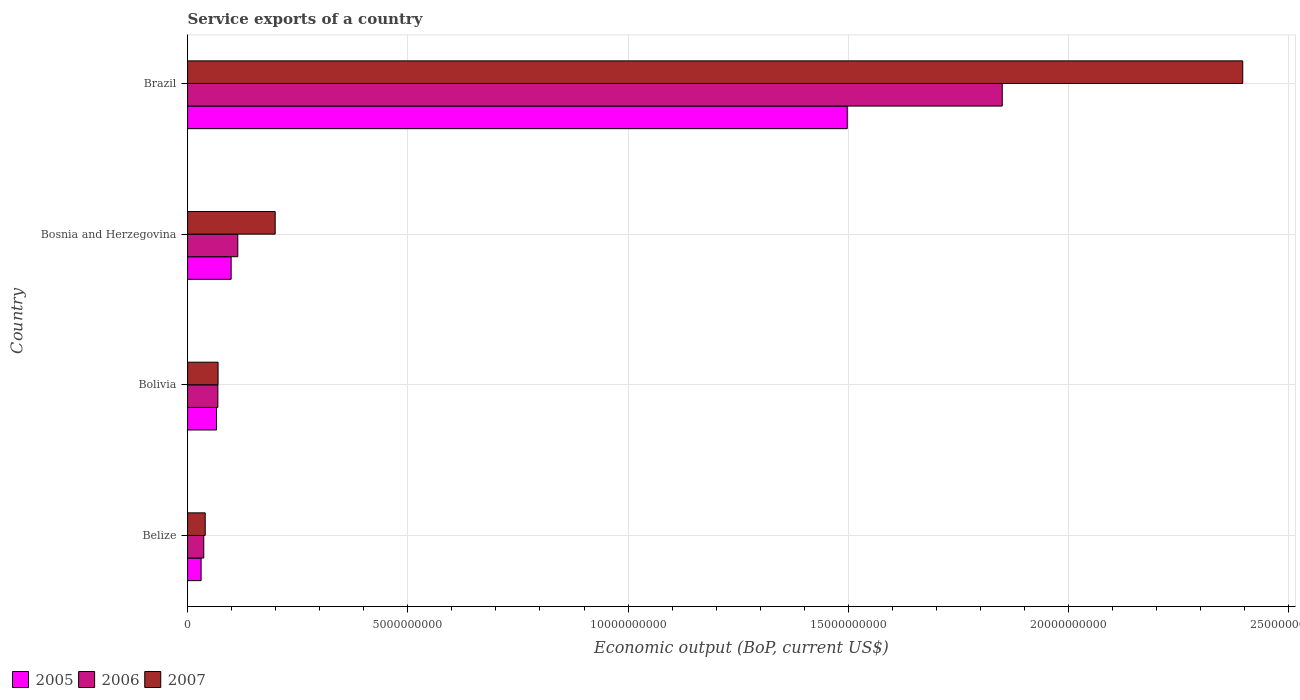How many groups of bars are there?
Make the answer very short. 4. Are the number of bars per tick equal to the number of legend labels?
Your response must be concise. Yes. Are the number of bars on each tick of the Y-axis equal?
Offer a terse response. Yes. How many bars are there on the 4th tick from the top?
Make the answer very short. 3. What is the label of the 2nd group of bars from the top?
Your response must be concise. Bosnia and Herzegovina. In how many cases, is the number of bars for a given country not equal to the number of legend labels?
Offer a very short reply. 0. What is the service exports in 2005 in Bolivia?
Your answer should be very brief. 6.57e+08. Across all countries, what is the maximum service exports in 2005?
Give a very brief answer. 1.50e+1. Across all countries, what is the minimum service exports in 2007?
Provide a succinct answer. 4.00e+08. In which country was the service exports in 2006 minimum?
Your response must be concise. Belize. What is the total service exports in 2007 in the graph?
Your response must be concise. 2.70e+1. What is the difference between the service exports in 2005 in Bolivia and that in Brazil?
Keep it short and to the point. -1.43e+1. What is the difference between the service exports in 2006 in Bolivia and the service exports in 2005 in Belize?
Provide a short and direct response. 3.80e+08. What is the average service exports in 2007 per country?
Keep it short and to the point. 6.76e+09. What is the difference between the service exports in 2007 and service exports in 2005 in Bolivia?
Give a very brief answer. 3.47e+07. What is the ratio of the service exports in 2006 in Belize to that in Brazil?
Provide a succinct answer. 0.02. What is the difference between the highest and the second highest service exports in 2005?
Your answer should be compact. 1.40e+1. What is the difference between the highest and the lowest service exports in 2007?
Make the answer very short. 2.36e+1. In how many countries, is the service exports in 2006 greater than the average service exports in 2006 taken over all countries?
Provide a short and direct response. 1. What does the 2nd bar from the top in Belize represents?
Provide a succinct answer. 2006. How many bars are there?
Provide a short and direct response. 12. Are all the bars in the graph horizontal?
Provide a short and direct response. Yes. How many countries are there in the graph?
Offer a terse response. 4. What is the difference between two consecutive major ticks on the X-axis?
Give a very brief answer. 5.00e+09. Are the values on the major ticks of X-axis written in scientific E-notation?
Your response must be concise. No. Does the graph contain any zero values?
Provide a succinct answer. No. What is the title of the graph?
Provide a short and direct response. Service exports of a country. Does "1961" appear as one of the legend labels in the graph?
Make the answer very short. No. What is the label or title of the X-axis?
Offer a very short reply. Economic output (BoP, current US$). What is the label or title of the Y-axis?
Give a very brief answer. Country. What is the Economic output (BoP, current US$) in 2005 in Belize?
Your answer should be compact. 3.07e+08. What is the Economic output (BoP, current US$) in 2006 in Belize?
Provide a short and direct response. 3.67e+08. What is the Economic output (BoP, current US$) in 2007 in Belize?
Your answer should be very brief. 4.00e+08. What is the Economic output (BoP, current US$) of 2005 in Bolivia?
Provide a short and direct response. 6.57e+08. What is the Economic output (BoP, current US$) of 2006 in Bolivia?
Provide a succinct answer. 6.87e+08. What is the Economic output (BoP, current US$) in 2007 in Bolivia?
Provide a short and direct response. 6.92e+08. What is the Economic output (BoP, current US$) in 2005 in Bosnia and Herzegovina?
Provide a short and direct response. 9.89e+08. What is the Economic output (BoP, current US$) in 2006 in Bosnia and Herzegovina?
Provide a succinct answer. 1.14e+09. What is the Economic output (BoP, current US$) in 2007 in Bosnia and Herzegovina?
Ensure brevity in your answer.  1.99e+09. What is the Economic output (BoP, current US$) in 2005 in Brazil?
Make the answer very short. 1.50e+1. What is the Economic output (BoP, current US$) of 2006 in Brazil?
Offer a very short reply. 1.85e+1. What is the Economic output (BoP, current US$) in 2007 in Brazil?
Give a very brief answer. 2.40e+1. Across all countries, what is the maximum Economic output (BoP, current US$) in 2005?
Provide a succinct answer. 1.50e+1. Across all countries, what is the maximum Economic output (BoP, current US$) in 2006?
Provide a short and direct response. 1.85e+1. Across all countries, what is the maximum Economic output (BoP, current US$) in 2007?
Offer a terse response. 2.40e+1. Across all countries, what is the minimum Economic output (BoP, current US$) of 2005?
Ensure brevity in your answer.  3.07e+08. Across all countries, what is the minimum Economic output (BoP, current US$) of 2006?
Make the answer very short. 3.67e+08. Across all countries, what is the minimum Economic output (BoP, current US$) of 2007?
Your answer should be very brief. 4.00e+08. What is the total Economic output (BoP, current US$) of 2005 in the graph?
Your response must be concise. 1.69e+1. What is the total Economic output (BoP, current US$) in 2006 in the graph?
Your answer should be compact. 2.07e+1. What is the total Economic output (BoP, current US$) of 2007 in the graph?
Keep it short and to the point. 2.70e+1. What is the difference between the Economic output (BoP, current US$) in 2005 in Belize and that in Bolivia?
Keep it short and to the point. -3.50e+08. What is the difference between the Economic output (BoP, current US$) in 2006 in Belize and that in Bolivia?
Give a very brief answer. -3.20e+08. What is the difference between the Economic output (BoP, current US$) in 2007 in Belize and that in Bolivia?
Ensure brevity in your answer.  -2.92e+08. What is the difference between the Economic output (BoP, current US$) of 2005 in Belize and that in Bosnia and Herzegovina?
Your response must be concise. -6.82e+08. What is the difference between the Economic output (BoP, current US$) in 2006 in Belize and that in Bosnia and Herzegovina?
Your response must be concise. -7.73e+08. What is the difference between the Economic output (BoP, current US$) of 2007 in Belize and that in Bosnia and Herzegovina?
Your response must be concise. -1.59e+09. What is the difference between the Economic output (BoP, current US$) in 2005 in Belize and that in Brazil?
Give a very brief answer. -1.47e+1. What is the difference between the Economic output (BoP, current US$) in 2006 in Belize and that in Brazil?
Your answer should be compact. -1.81e+1. What is the difference between the Economic output (BoP, current US$) in 2007 in Belize and that in Brazil?
Give a very brief answer. -2.36e+1. What is the difference between the Economic output (BoP, current US$) of 2005 in Bolivia and that in Bosnia and Herzegovina?
Provide a short and direct response. -3.32e+08. What is the difference between the Economic output (BoP, current US$) in 2006 in Bolivia and that in Bosnia and Herzegovina?
Offer a very short reply. -4.52e+08. What is the difference between the Economic output (BoP, current US$) in 2007 in Bolivia and that in Bosnia and Herzegovina?
Offer a terse response. -1.30e+09. What is the difference between the Economic output (BoP, current US$) of 2005 in Bolivia and that in Brazil?
Keep it short and to the point. -1.43e+1. What is the difference between the Economic output (BoP, current US$) in 2006 in Bolivia and that in Brazil?
Give a very brief answer. -1.78e+1. What is the difference between the Economic output (BoP, current US$) in 2007 in Bolivia and that in Brazil?
Your answer should be compact. -2.33e+1. What is the difference between the Economic output (BoP, current US$) of 2005 in Bosnia and Herzegovina and that in Brazil?
Your answer should be compact. -1.40e+1. What is the difference between the Economic output (BoP, current US$) of 2006 in Bosnia and Herzegovina and that in Brazil?
Make the answer very short. -1.74e+1. What is the difference between the Economic output (BoP, current US$) in 2007 in Bosnia and Herzegovina and that in Brazil?
Offer a terse response. -2.20e+1. What is the difference between the Economic output (BoP, current US$) in 2005 in Belize and the Economic output (BoP, current US$) in 2006 in Bolivia?
Give a very brief answer. -3.80e+08. What is the difference between the Economic output (BoP, current US$) in 2005 in Belize and the Economic output (BoP, current US$) in 2007 in Bolivia?
Offer a very short reply. -3.85e+08. What is the difference between the Economic output (BoP, current US$) in 2006 in Belize and the Economic output (BoP, current US$) in 2007 in Bolivia?
Your answer should be very brief. -3.25e+08. What is the difference between the Economic output (BoP, current US$) in 2005 in Belize and the Economic output (BoP, current US$) in 2006 in Bosnia and Herzegovina?
Provide a short and direct response. -8.33e+08. What is the difference between the Economic output (BoP, current US$) of 2005 in Belize and the Economic output (BoP, current US$) of 2007 in Bosnia and Herzegovina?
Provide a succinct answer. -1.68e+09. What is the difference between the Economic output (BoP, current US$) of 2006 in Belize and the Economic output (BoP, current US$) of 2007 in Bosnia and Herzegovina?
Provide a succinct answer. -1.62e+09. What is the difference between the Economic output (BoP, current US$) in 2005 in Belize and the Economic output (BoP, current US$) in 2006 in Brazil?
Keep it short and to the point. -1.82e+1. What is the difference between the Economic output (BoP, current US$) in 2005 in Belize and the Economic output (BoP, current US$) in 2007 in Brazil?
Ensure brevity in your answer.  -2.36e+1. What is the difference between the Economic output (BoP, current US$) of 2006 in Belize and the Economic output (BoP, current US$) of 2007 in Brazil?
Ensure brevity in your answer.  -2.36e+1. What is the difference between the Economic output (BoP, current US$) in 2005 in Bolivia and the Economic output (BoP, current US$) in 2006 in Bosnia and Herzegovina?
Keep it short and to the point. -4.83e+08. What is the difference between the Economic output (BoP, current US$) in 2005 in Bolivia and the Economic output (BoP, current US$) in 2007 in Bosnia and Herzegovina?
Keep it short and to the point. -1.33e+09. What is the difference between the Economic output (BoP, current US$) in 2006 in Bolivia and the Economic output (BoP, current US$) in 2007 in Bosnia and Herzegovina?
Make the answer very short. -1.30e+09. What is the difference between the Economic output (BoP, current US$) of 2005 in Bolivia and the Economic output (BoP, current US$) of 2006 in Brazil?
Your answer should be very brief. -1.78e+1. What is the difference between the Economic output (BoP, current US$) in 2005 in Bolivia and the Economic output (BoP, current US$) in 2007 in Brazil?
Offer a very short reply. -2.33e+1. What is the difference between the Economic output (BoP, current US$) in 2006 in Bolivia and the Economic output (BoP, current US$) in 2007 in Brazil?
Make the answer very short. -2.33e+1. What is the difference between the Economic output (BoP, current US$) of 2005 in Bosnia and Herzegovina and the Economic output (BoP, current US$) of 2006 in Brazil?
Your response must be concise. -1.75e+1. What is the difference between the Economic output (BoP, current US$) in 2005 in Bosnia and Herzegovina and the Economic output (BoP, current US$) in 2007 in Brazil?
Your answer should be very brief. -2.30e+1. What is the difference between the Economic output (BoP, current US$) in 2006 in Bosnia and Herzegovina and the Economic output (BoP, current US$) in 2007 in Brazil?
Offer a terse response. -2.28e+1. What is the average Economic output (BoP, current US$) of 2005 per country?
Offer a terse response. 4.23e+09. What is the average Economic output (BoP, current US$) in 2006 per country?
Offer a terse response. 5.17e+09. What is the average Economic output (BoP, current US$) in 2007 per country?
Your response must be concise. 6.76e+09. What is the difference between the Economic output (BoP, current US$) of 2005 and Economic output (BoP, current US$) of 2006 in Belize?
Make the answer very short. -6.01e+07. What is the difference between the Economic output (BoP, current US$) in 2005 and Economic output (BoP, current US$) in 2007 in Belize?
Your answer should be very brief. -9.31e+07. What is the difference between the Economic output (BoP, current US$) in 2006 and Economic output (BoP, current US$) in 2007 in Belize?
Give a very brief answer. -3.31e+07. What is the difference between the Economic output (BoP, current US$) of 2005 and Economic output (BoP, current US$) of 2006 in Bolivia?
Keep it short and to the point. -3.02e+07. What is the difference between the Economic output (BoP, current US$) of 2005 and Economic output (BoP, current US$) of 2007 in Bolivia?
Provide a succinct answer. -3.47e+07. What is the difference between the Economic output (BoP, current US$) of 2006 and Economic output (BoP, current US$) of 2007 in Bolivia?
Ensure brevity in your answer.  -4.51e+06. What is the difference between the Economic output (BoP, current US$) of 2005 and Economic output (BoP, current US$) of 2006 in Bosnia and Herzegovina?
Ensure brevity in your answer.  -1.51e+08. What is the difference between the Economic output (BoP, current US$) in 2005 and Economic output (BoP, current US$) in 2007 in Bosnia and Herzegovina?
Provide a short and direct response. -1.00e+09. What is the difference between the Economic output (BoP, current US$) of 2006 and Economic output (BoP, current US$) of 2007 in Bosnia and Herzegovina?
Your response must be concise. -8.49e+08. What is the difference between the Economic output (BoP, current US$) in 2005 and Economic output (BoP, current US$) in 2006 in Brazil?
Make the answer very short. -3.52e+09. What is the difference between the Economic output (BoP, current US$) of 2005 and Economic output (BoP, current US$) of 2007 in Brazil?
Keep it short and to the point. -8.98e+09. What is the difference between the Economic output (BoP, current US$) of 2006 and Economic output (BoP, current US$) of 2007 in Brazil?
Keep it short and to the point. -5.46e+09. What is the ratio of the Economic output (BoP, current US$) in 2005 in Belize to that in Bolivia?
Offer a terse response. 0.47. What is the ratio of the Economic output (BoP, current US$) of 2006 in Belize to that in Bolivia?
Your answer should be compact. 0.53. What is the ratio of the Economic output (BoP, current US$) in 2007 in Belize to that in Bolivia?
Make the answer very short. 0.58. What is the ratio of the Economic output (BoP, current US$) in 2005 in Belize to that in Bosnia and Herzegovina?
Your answer should be very brief. 0.31. What is the ratio of the Economic output (BoP, current US$) in 2006 in Belize to that in Bosnia and Herzegovina?
Provide a succinct answer. 0.32. What is the ratio of the Economic output (BoP, current US$) of 2007 in Belize to that in Bosnia and Herzegovina?
Make the answer very short. 0.2. What is the ratio of the Economic output (BoP, current US$) in 2005 in Belize to that in Brazil?
Make the answer very short. 0.02. What is the ratio of the Economic output (BoP, current US$) in 2006 in Belize to that in Brazil?
Offer a terse response. 0.02. What is the ratio of the Economic output (BoP, current US$) in 2007 in Belize to that in Brazil?
Make the answer very short. 0.02. What is the ratio of the Economic output (BoP, current US$) in 2005 in Bolivia to that in Bosnia and Herzegovina?
Offer a terse response. 0.66. What is the ratio of the Economic output (BoP, current US$) in 2006 in Bolivia to that in Bosnia and Herzegovina?
Provide a short and direct response. 0.6. What is the ratio of the Economic output (BoP, current US$) of 2007 in Bolivia to that in Bosnia and Herzegovina?
Ensure brevity in your answer.  0.35. What is the ratio of the Economic output (BoP, current US$) of 2005 in Bolivia to that in Brazil?
Ensure brevity in your answer.  0.04. What is the ratio of the Economic output (BoP, current US$) of 2006 in Bolivia to that in Brazil?
Make the answer very short. 0.04. What is the ratio of the Economic output (BoP, current US$) in 2007 in Bolivia to that in Brazil?
Provide a short and direct response. 0.03. What is the ratio of the Economic output (BoP, current US$) of 2005 in Bosnia and Herzegovina to that in Brazil?
Your answer should be very brief. 0.07. What is the ratio of the Economic output (BoP, current US$) of 2006 in Bosnia and Herzegovina to that in Brazil?
Your answer should be very brief. 0.06. What is the ratio of the Economic output (BoP, current US$) in 2007 in Bosnia and Herzegovina to that in Brazil?
Make the answer very short. 0.08. What is the difference between the highest and the second highest Economic output (BoP, current US$) of 2005?
Your answer should be compact. 1.40e+1. What is the difference between the highest and the second highest Economic output (BoP, current US$) in 2006?
Your answer should be very brief. 1.74e+1. What is the difference between the highest and the second highest Economic output (BoP, current US$) in 2007?
Offer a very short reply. 2.20e+1. What is the difference between the highest and the lowest Economic output (BoP, current US$) of 2005?
Offer a terse response. 1.47e+1. What is the difference between the highest and the lowest Economic output (BoP, current US$) of 2006?
Give a very brief answer. 1.81e+1. What is the difference between the highest and the lowest Economic output (BoP, current US$) of 2007?
Your answer should be compact. 2.36e+1. 